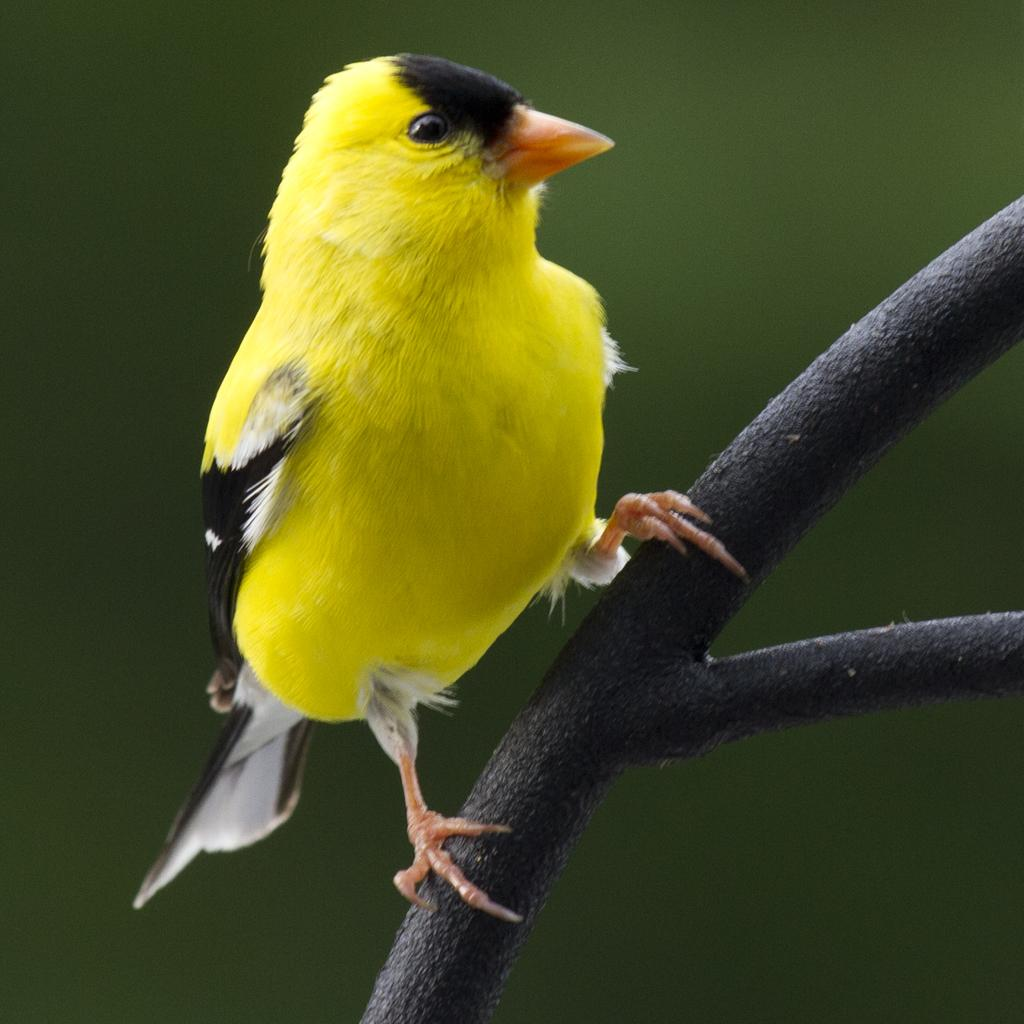What is present on the branch in the image? There is a yellow bird on the branch. What can be seen in the foreground of the image? There is a branch in the image. How would you describe the background of the image? The background of the image is blurred. What type of collar is the bird wearing in the image? There is no collar visible on the bird in the image. 